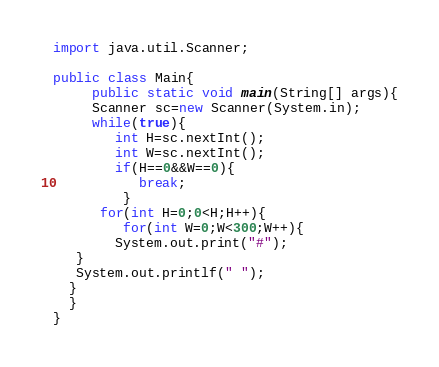Convert code to text. <code><loc_0><loc_0><loc_500><loc_500><_Java_>import java.util.Scanner;

public class Main{
     public static void main(String[] args){
     Scanner sc=new Scanner(System.in);
     while(true){
        int H=sc.nextInt();
        int W=sc.nextInt();
        if(H==0&&W==0){
           break;
         }
      for(int H=0;0<H;H++){
         for(int W=0;W<300;W++){
        System.out.print("#");
   }
   System.out.printlf(" ");
  }
  }
}</code> 